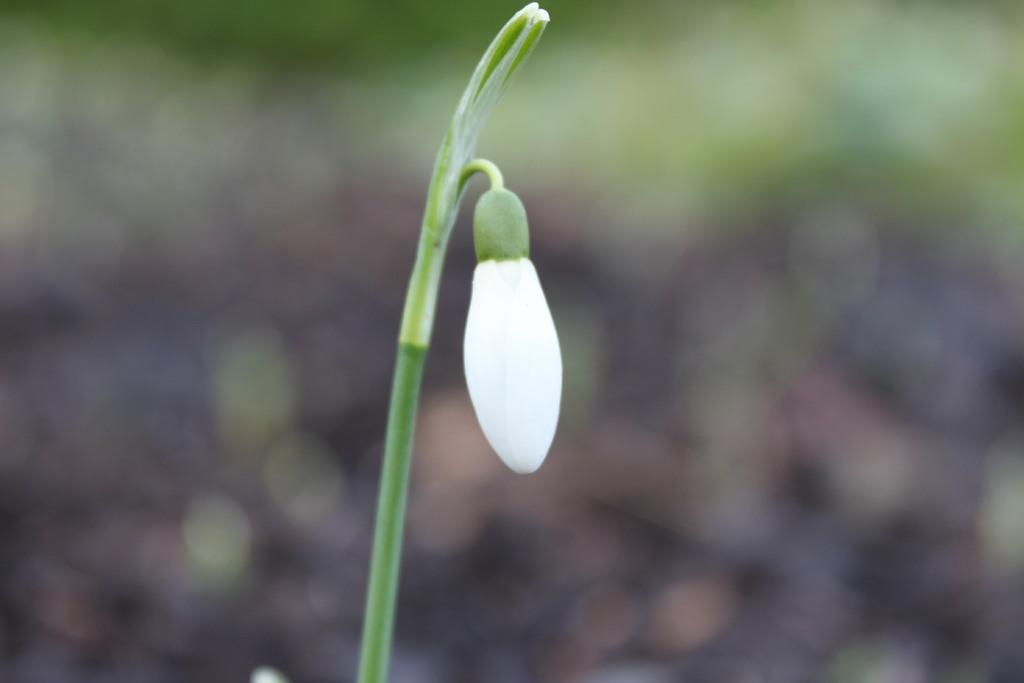What is the main subject in the center of the image? There is a bug in the center of the image. What color is the bug? The bug is white in color. What else can be seen in the image besides the bug? There is a stem in the image. What type of cabbage is the bug sitting on in the image? There is no cabbage present in the image; it only features a bug and a stem. Can you tell me how many shoes are visible in the image? There are no shoes visible in the image. 